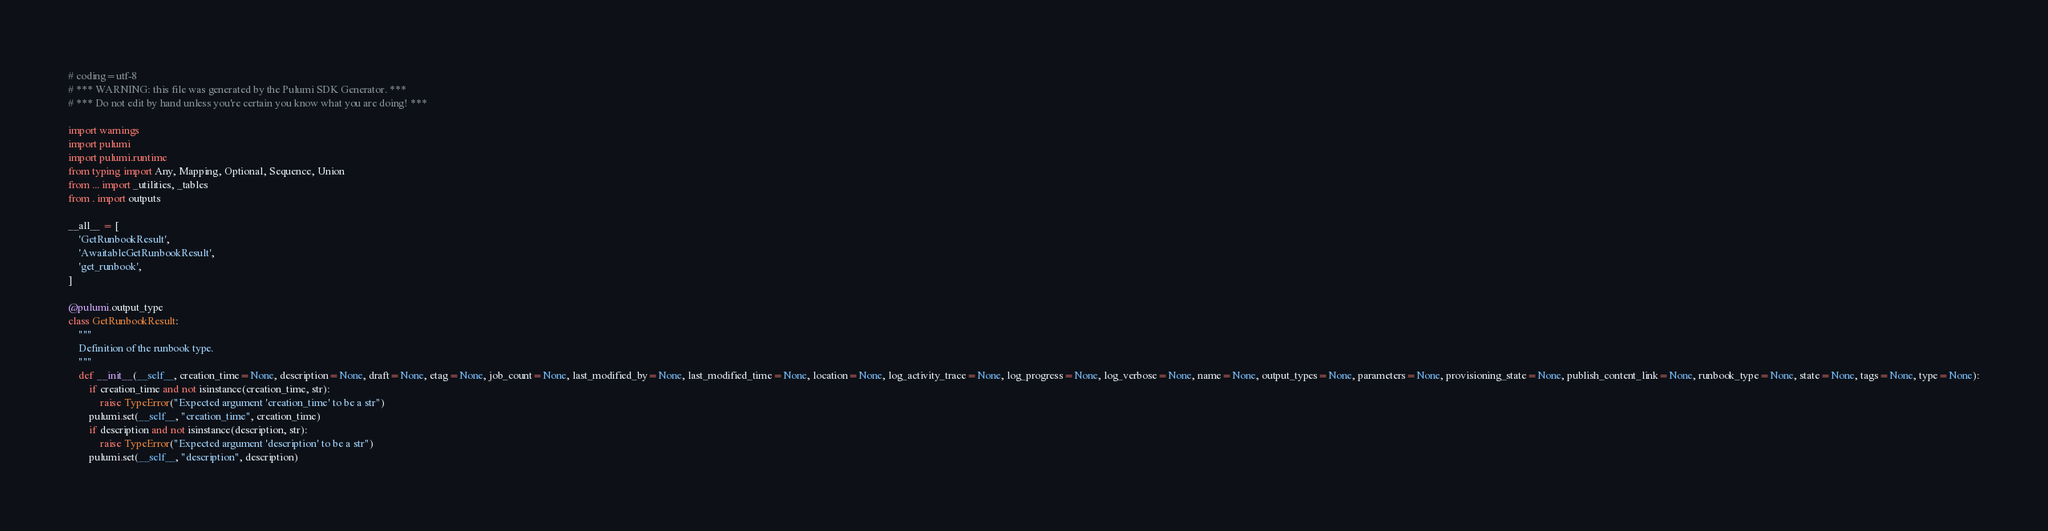<code> <loc_0><loc_0><loc_500><loc_500><_Python_># coding=utf-8
# *** WARNING: this file was generated by the Pulumi SDK Generator. ***
# *** Do not edit by hand unless you're certain you know what you are doing! ***

import warnings
import pulumi
import pulumi.runtime
from typing import Any, Mapping, Optional, Sequence, Union
from ... import _utilities, _tables
from . import outputs

__all__ = [
    'GetRunbookResult',
    'AwaitableGetRunbookResult',
    'get_runbook',
]

@pulumi.output_type
class GetRunbookResult:
    """
    Definition of the runbook type.
    """
    def __init__(__self__, creation_time=None, description=None, draft=None, etag=None, job_count=None, last_modified_by=None, last_modified_time=None, location=None, log_activity_trace=None, log_progress=None, log_verbose=None, name=None, output_types=None, parameters=None, provisioning_state=None, publish_content_link=None, runbook_type=None, state=None, tags=None, type=None):
        if creation_time and not isinstance(creation_time, str):
            raise TypeError("Expected argument 'creation_time' to be a str")
        pulumi.set(__self__, "creation_time", creation_time)
        if description and not isinstance(description, str):
            raise TypeError("Expected argument 'description' to be a str")
        pulumi.set(__self__, "description", description)</code> 